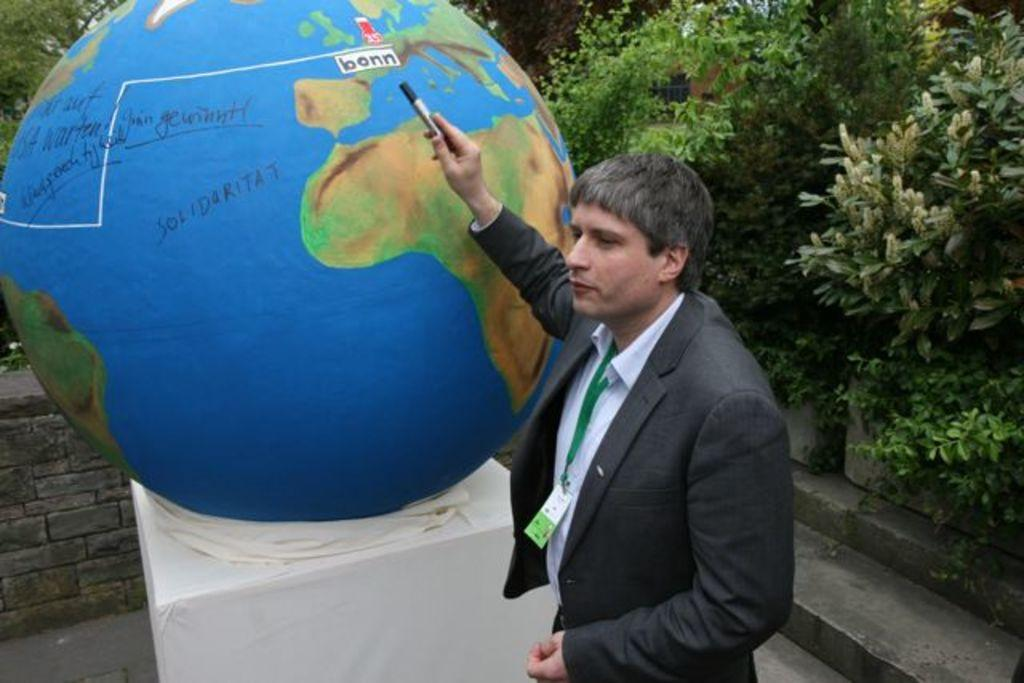What type of vegetation can be seen in the image? There are trees in the image. What object in the image represents the Earth? There is a globe in the image. What type of structure is visible in the background? There is a brick wall in the image. Who is present in the image? There is a man in the image. What is the man wearing? The man is wearing a black jacket. What is the man holding in the image? The man is holding a marker. What is the father's name in the image? There is no mention of a father or any names in the image. How hot is the temperature in the image? The temperature is not mentioned in the image. 